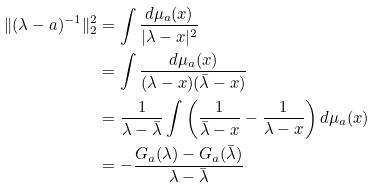Convert formula to latex. <formula><loc_0><loc_0><loc_500><loc_500>\| ( \lambda - a ) ^ { - 1 } \| _ { 2 } ^ { 2 } & = \int \frac { d \mu _ { a } ( x ) } { | \lambda - x | ^ { 2 } } \\ & = \int \frac { d \mu _ { a } ( x ) } { ( \lambda - x ) ( \bar { \lambda } - x ) } \\ & = \frac { 1 } { \lambda - \bar { \lambda } } \int \left ( \frac { 1 } { \bar { \lambda } - x } - \frac { 1 } { \lambda - x } \right ) d \mu _ { a } ( x ) \\ & = - \frac { G _ { a } ( \lambda ) - G _ { a } ( \bar { \lambda } ) } { \lambda - \bar { \lambda } }</formula> 